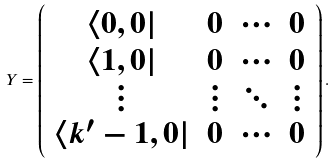Convert formula to latex. <formula><loc_0><loc_0><loc_500><loc_500>Y = \left ( \begin{array} { c c c c } \langle 0 , 0 | & 0 & \cdots & 0 \\ \langle 1 , 0 | & 0 & \cdots & 0 \\ \vdots & \vdots & \ddots & \vdots \\ \langle k ^ { \prime } - 1 , 0 | & 0 & \cdots & 0 \end{array} \right ) .</formula> 